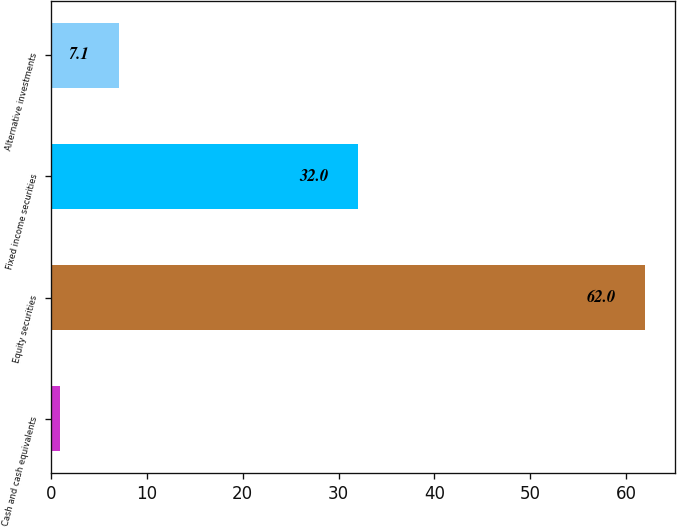<chart> <loc_0><loc_0><loc_500><loc_500><bar_chart><fcel>Cash and cash equivalents<fcel>Equity securities<fcel>Fixed income securities<fcel>Alternative investments<nl><fcel>1<fcel>62<fcel>32<fcel>7.1<nl></chart> 